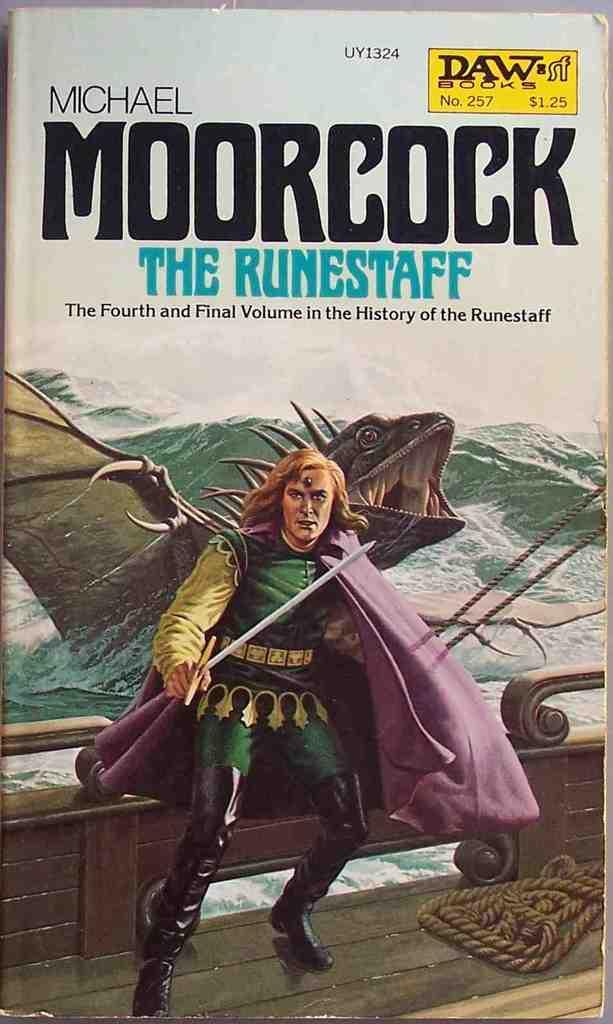What is the man in the image wearing? The man in the image is wearing a costume. What type of animal is in the image? There is an animal in the image. What geographical feature can be seen in the image? There are mountains in the image. What else is present in the image besides the man and the animal? There is text and the sky visible in the image. What type of quartz can be seen in the image? There is no quartz present in the image. How does the wilderness affect the man and the animal in the image? The image does not depict a wilderness setting, so it cannot be determined how the wilderness might affect the man and the animal. 